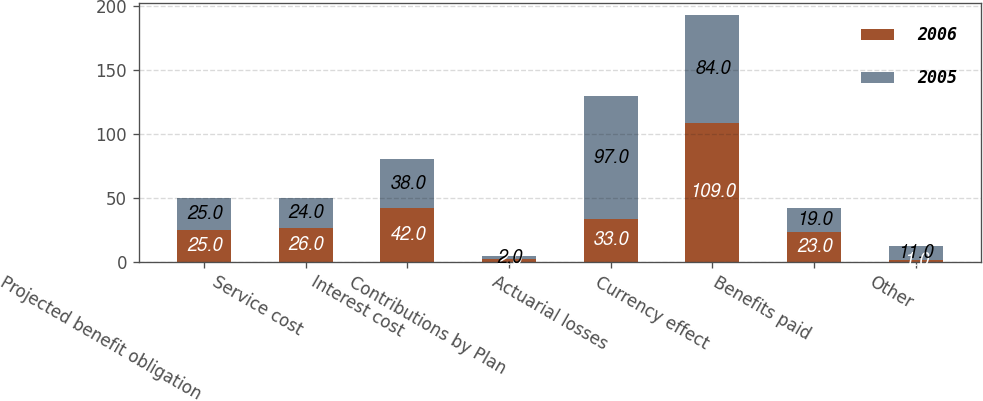Convert chart to OTSL. <chart><loc_0><loc_0><loc_500><loc_500><stacked_bar_chart><ecel><fcel>Projected benefit obligation<fcel>Service cost<fcel>Interest cost<fcel>Contributions by Plan<fcel>Actuarial losses<fcel>Currency effect<fcel>Benefits paid<fcel>Other<nl><fcel>2006<fcel>25<fcel>26<fcel>42<fcel>2<fcel>33<fcel>109<fcel>23<fcel>1<nl><fcel>2005<fcel>25<fcel>24<fcel>38<fcel>2<fcel>97<fcel>84<fcel>19<fcel>11<nl></chart> 